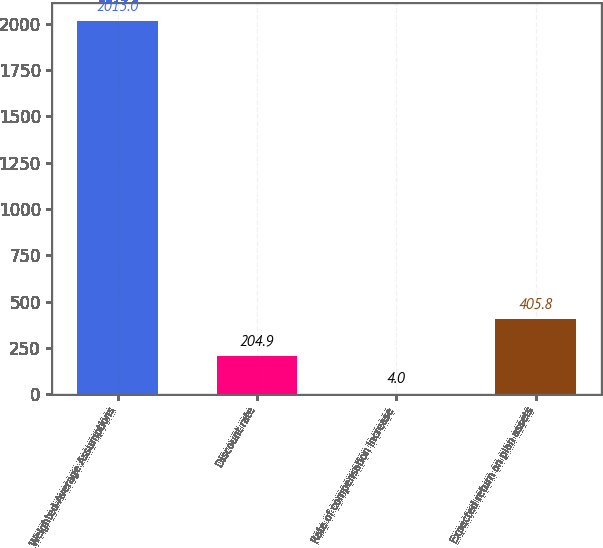Convert chart. <chart><loc_0><loc_0><loc_500><loc_500><bar_chart><fcel>Weighted-Average Assumptions<fcel>Discount rate<fcel>Rate of compensation increase<fcel>Expected return on plan assets<nl><fcel>2013<fcel>204.9<fcel>4<fcel>405.8<nl></chart> 